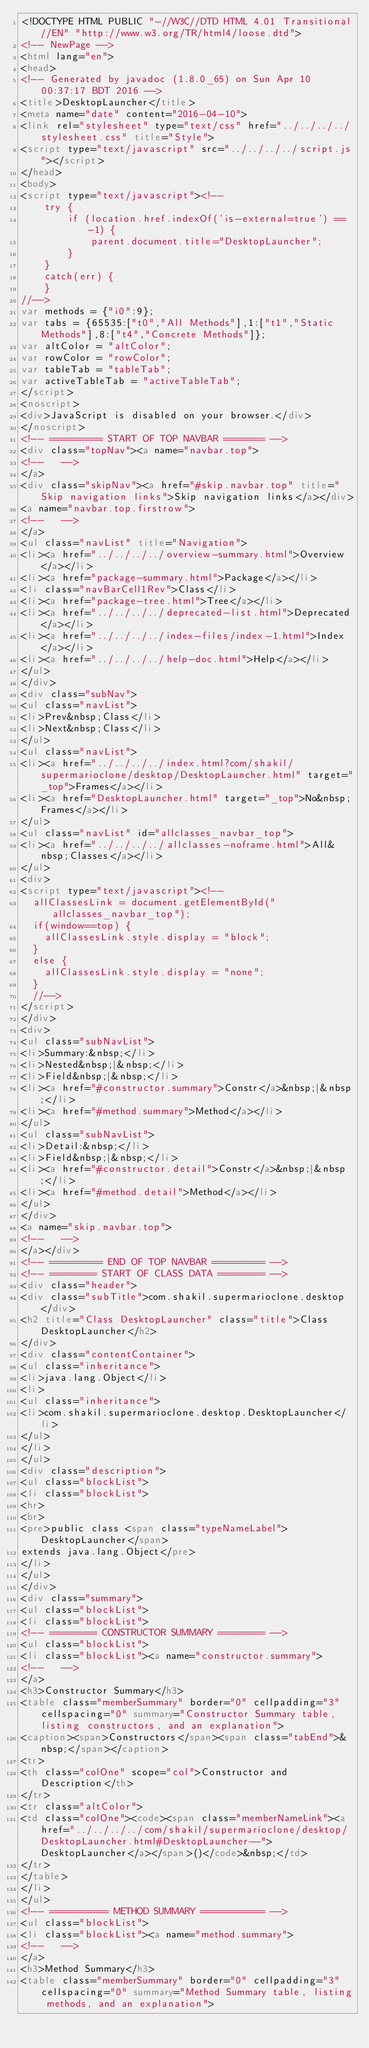Convert code to text. <code><loc_0><loc_0><loc_500><loc_500><_HTML_><!DOCTYPE HTML PUBLIC "-//W3C//DTD HTML 4.01 Transitional//EN" "http://www.w3.org/TR/html4/loose.dtd">
<!-- NewPage -->
<html lang="en">
<head>
<!-- Generated by javadoc (1.8.0_65) on Sun Apr 10 00:37:17 BDT 2016 -->
<title>DesktopLauncher</title>
<meta name="date" content="2016-04-10">
<link rel="stylesheet" type="text/css" href="../../../../stylesheet.css" title="Style">
<script type="text/javascript" src="../../../../script.js"></script>
</head>
<body>
<script type="text/javascript"><!--
    try {
        if (location.href.indexOf('is-external=true') == -1) {
            parent.document.title="DesktopLauncher";
        }
    }
    catch(err) {
    }
//-->
var methods = {"i0":9};
var tabs = {65535:["t0","All Methods"],1:["t1","Static Methods"],8:["t4","Concrete Methods"]};
var altColor = "altColor";
var rowColor = "rowColor";
var tableTab = "tableTab";
var activeTableTab = "activeTableTab";
</script>
<noscript>
<div>JavaScript is disabled on your browser.</div>
</noscript>
<!-- ========= START OF TOP NAVBAR ======= -->
<div class="topNav"><a name="navbar.top">
<!--   -->
</a>
<div class="skipNav"><a href="#skip.navbar.top" title="Skip navigation links">Skip navigation links</a></div>
<a name="navbar.top.firstrow">
<!--   -->
</a>
<ul class="navList" title="Navigation">
<li><a href="../../../../overview-summary.html">Overview</a></li>
<li><a href="package-summary.html">Package</a></li>
<li class="navBarCell1Rev">Class</li>
<li><a href="package-tree.html">Tree</a></li>
<li><a href="../../../../deprecated-list.html">Deprecated</a></li>
<li><a href="../../../../index-files/index-1.html">Index</a></li>
<li><a href="../../../../help-doc.html">Help</a></li>
</ul>
</div>
<div class="subNav">
<ul class="navList">
<li>Prev&nbsp;Class</li>
<li>Next&nbsp;Class</li>
</ul>
<ul class="navList">
<li><a href="../../../../index.html?com/shakil/supermarioclone/desktop/DesktopLauncher.html" target="_top">Frames</a></li>
<li><a href="DesktopLauncher.html" target="_top">No&nbsp;Frames</a></li>
</ul>
<ul class="navList" id="allclasses_navbar_top">
<li><a href="../../../../allclasses-noframe.html">All&nbsp;Classes</a></li>
</ul>
<div>
<script type="text/javascript"><!--
  allClassesLink = document.getElementById("allclasses_navbar_top");
  if(window==top) {
    allClassesLink.style.display = "block";
  }
  else {
    allClassesLink.style.display = "none";
  }
  //-->
</script>
</div>
<div>
<ul class="subNavList">
<li>Summary:&nbsp;</li>
<li>Nested&nbsp;|&nbsp;</li>
<li>Field&nbsp;|&nbsp;</li>
<li><a href="#constructor.summary">Constr</a>&nbsp;|&nbsp;</li>
<li><a href="#method.summary">Method</a></li>
</ul>
<ul class="subNavList">
<li>Detail:&nbsp;</li>
<li>Field&nbsp;|&nbsp;</li>
<li><a href="#constructor.detail">Constr</a>&nbsp;|&nbsp;</li>
<li><a href="#method.detail">Method</a></li>
</ul>
</div>
<a name="skip.navbar.top">
<!--   -->
</a></div>
<!-- ========= END OF TOP NAVBAR ========= -->
<!-- ======== START OF CLASS DATA ======== -->
<div class="header">
<div class="subTitle">com.shakil.supermarioclone.desktop</div>
<h2 title="Class DesktopLauncher" class="title">Class DesktopLauncher</h2>
</div>
<div class="contentContainer">
<ul class="inheritance">
<li>java.lang.Object</li>
<li>
<ul class="inheritance">
<li>com.shakil.supermarioclone.desktop.DesktopLauncher</li>
</ul>
</li>
</ul>
<div class="description">
<ul class="blockList">
<li class="blockList">
<hr>
<br>
<pre>public class <span class="typeNameLabel">DesktopLauncher</span>
extends java.lang.Object</pre>
</li>
</ul>
</div>
<div class="summary">
<ul class="blockList">
<li class="blockList">
<!-- ======== CONSTRUCTOR SUMMARY ======== -->
<ul class="blockList">
<li class="blockList"><a name="constructor.summary">
<!--   -->
</a>
<h3>Constructor Summary</h3>
<table class="memberSummary" border="0" cellpadding="3" cellspacing="0" summary="Constructor Summary table, listing constructors, and an explanation">
<caption><span>Constructors</span><span class="tabEnd">&nbsp;</span></caption>
<tr>
<th class="colOne" scope="col">Constructor and Description</th>
</tr>
<tr class="altColor">
<td class="colOne"><code><span class="memberNameLink"><a href="../../../../com/shakil/supermarioclone/desktop/DesktopLauncher.html#DesktopLauncher--">DesktopLauncher</a></span>()</code>&nbsp;</td>
</tr>
</table>
</li>
</ul>
<!-- ========== METHOD SUMMARY =========== -->
<ul class="blockList">
<li class="blockList"><a name="method.summary">
<!--   -->
</a>
<h3>Method Summary</h3>
<table class="memberSummary" border="0" cellpadding="3" cellspacing="0" summary="Method Summary table, listing methods, and an explanation"></code> 